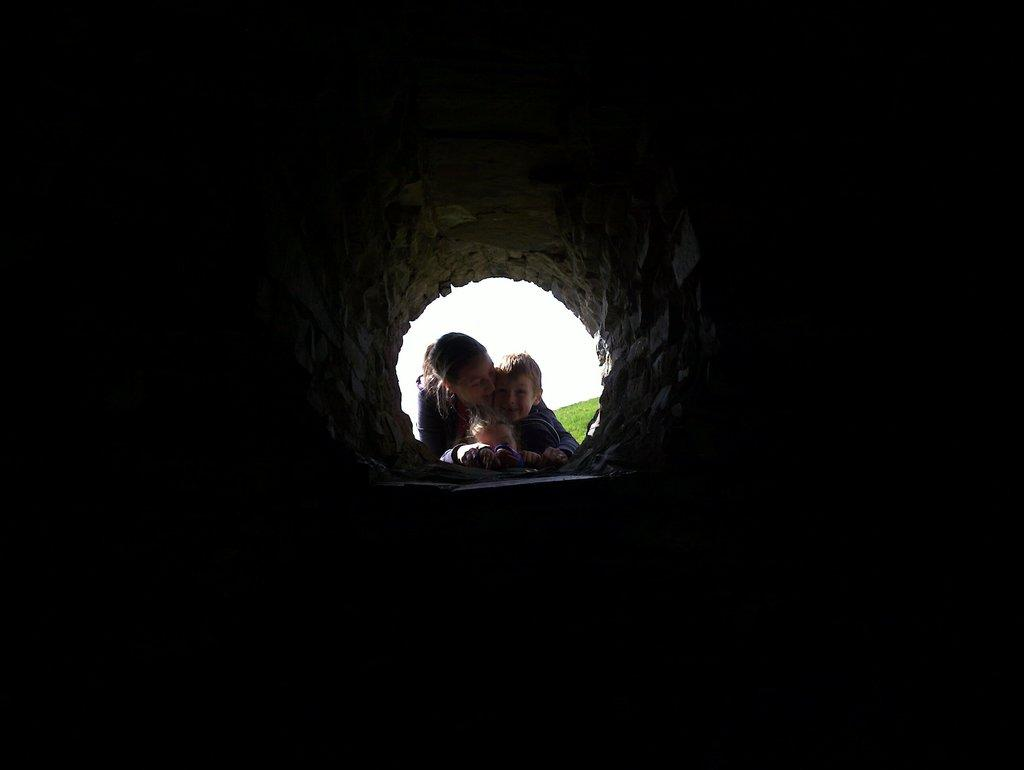Who is present in the image? There is a woman and two kids in the image. What is the setting of the image? The woman and kids are in front of a tunnel. What can be seen in the background of the image? There is sky visible in the background of the image. What type of representative is the woman in the image? There is no indication in the image that the woman is a representative of any kind. 